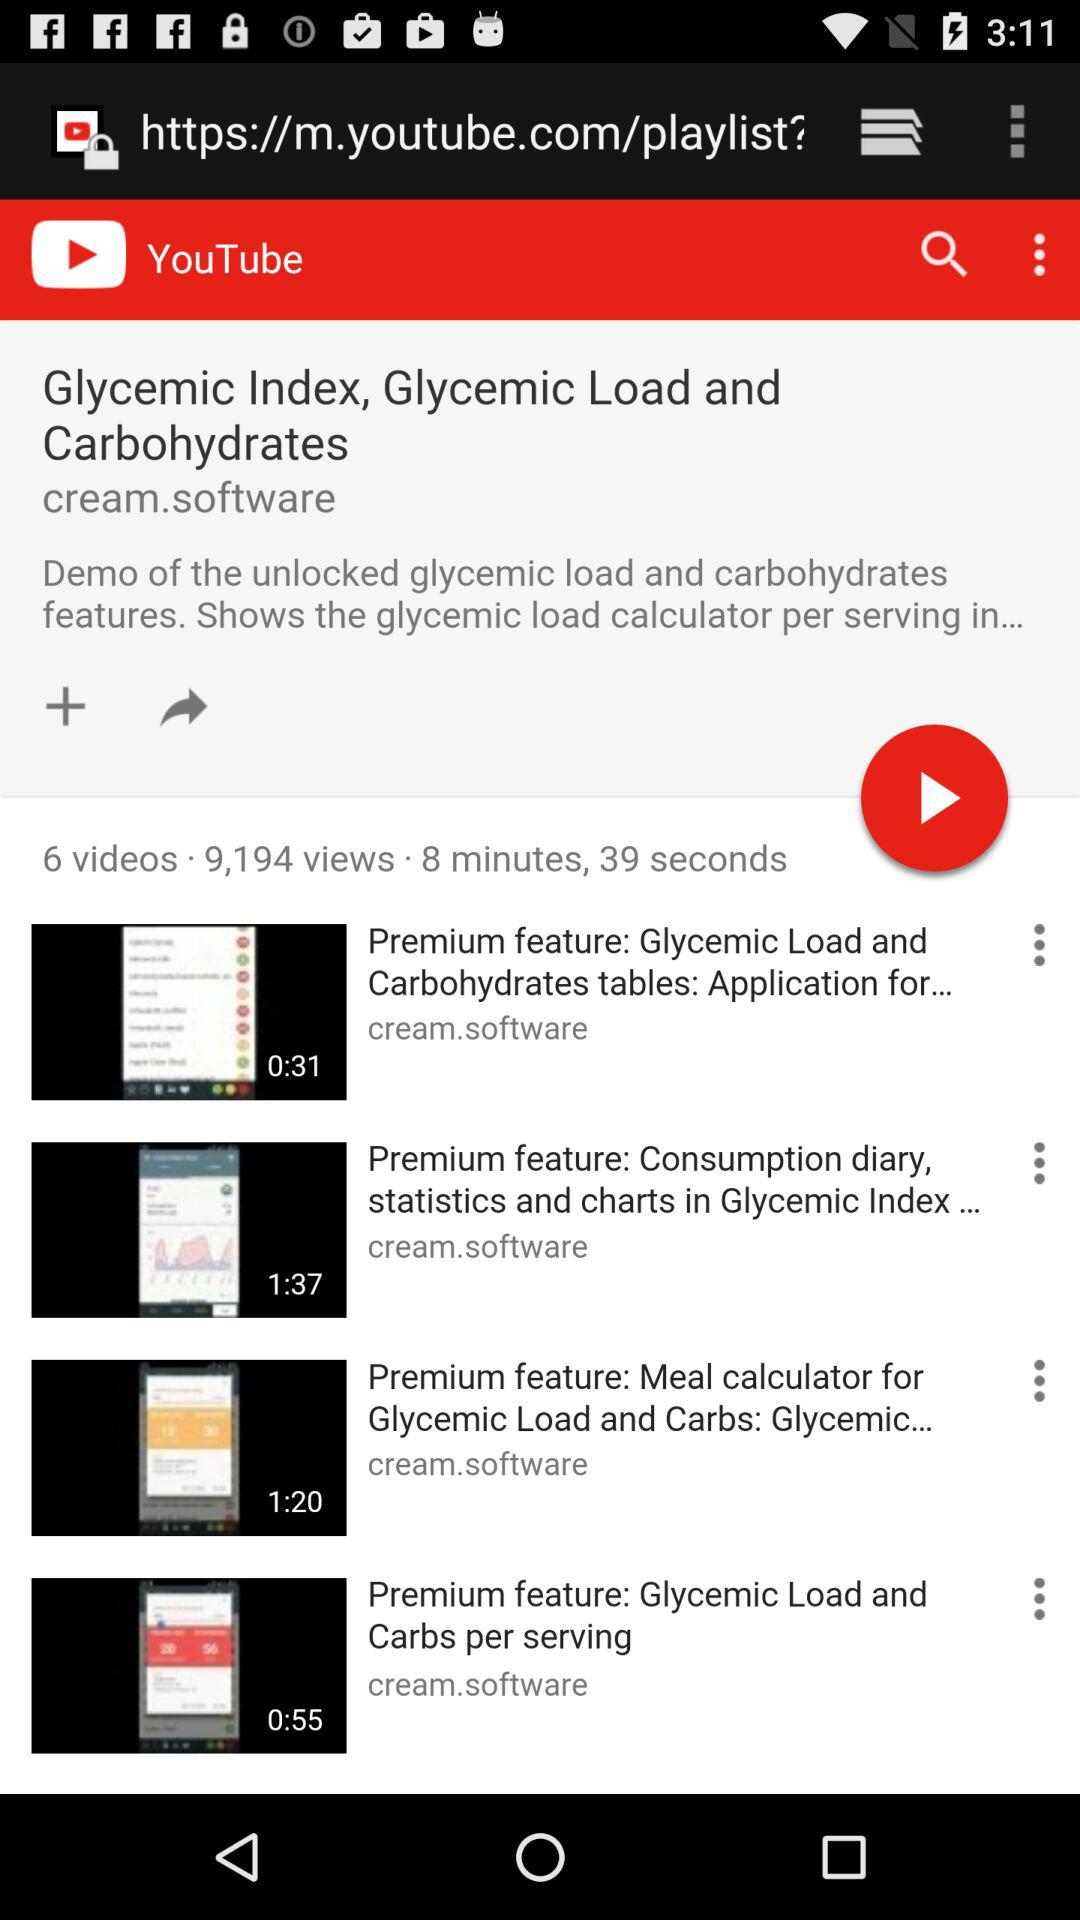What is the duration of the video titled "Premium feature: Glycemic Load and Carbs per serving"? The duration of the video is 55 seconds. 